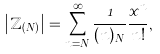<formula> <loc_0><loc_0><loc_500><loc_500>\left | \mathbb { Z } _ { ( N ) } \right | = \sum _ { n = N } ^ { \infty } \frac { 1 } { ( n ) _ { N } } \frac { x ^ { n } } { n ! } ,</formula> 